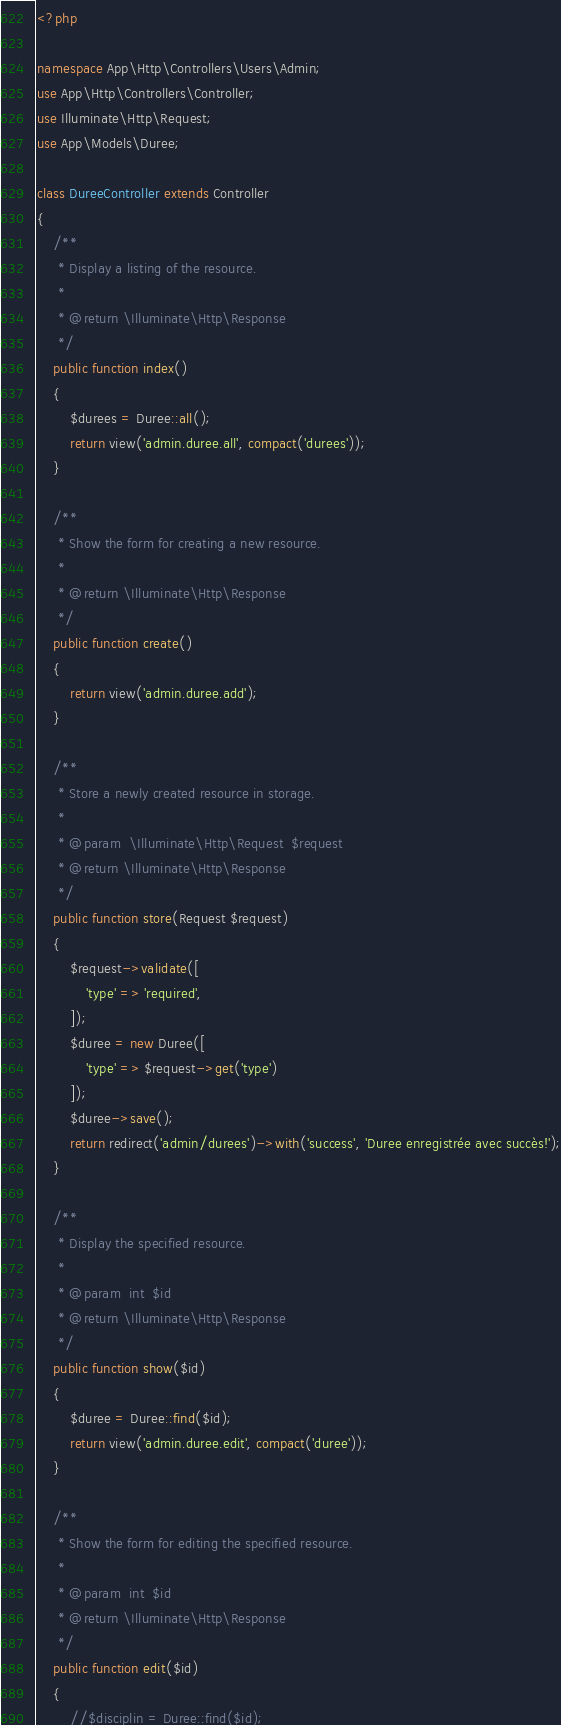Convert code to text. <code><loc_0><loc_0><loc_500><loc_500><_PHP_><?php

namespace App\Http\Controllers\Users\Admin;
use App\Http\Controllers\Controller;
use Illuminate\Http\Request;
use App\Models\Duree;

class DureeController extends Controller
{
    /**
     * Display a listing of the resource.
     *
     * @return \Illuminate\Http\Response
     */
    public function index()
    {
        $durees = Duree::all();
        return view('admin.duree.all', compact('durees'));
    }

    /**
     * Show the form for creating a new resource.
     *
     * @return \Illuminate\Http\Response
     */
    public function create()
    {
        return view('admin.duree.add');
    }

    /**
     * Store a newly created resource in storage.
     *
     * @param  \Illuminate\Http\Request  $request
     * @return \Illuminate\Http\Response
     */
    public function store(Request $request)
    {
        $request->validate([
            'type' => 'required',
        ]);
        $duree = new Duree([
            'type' => $request->get('type')
        ]);
        $duree->save();
        return redirect('admin/durees')->with('success', 'Duree enregistrée avec succès!');
    }

    /**
     * Display the specified resource.
     *
     * @param  int  $id
     * @return \Illuminate\Http\Response
     */
    public function show($id)
    {
        $duree = Duree::find($id);
        return view('admin.duree.edit', compact('duree'));
    }

    /**
     * Show the form for editing the specified resource.
     *
     * @param  int  $id
     * @return \Illuminate\Http\Response
     */
    public function edit($id)
    {
        //$disciplin = Duree::find($id);</code> 